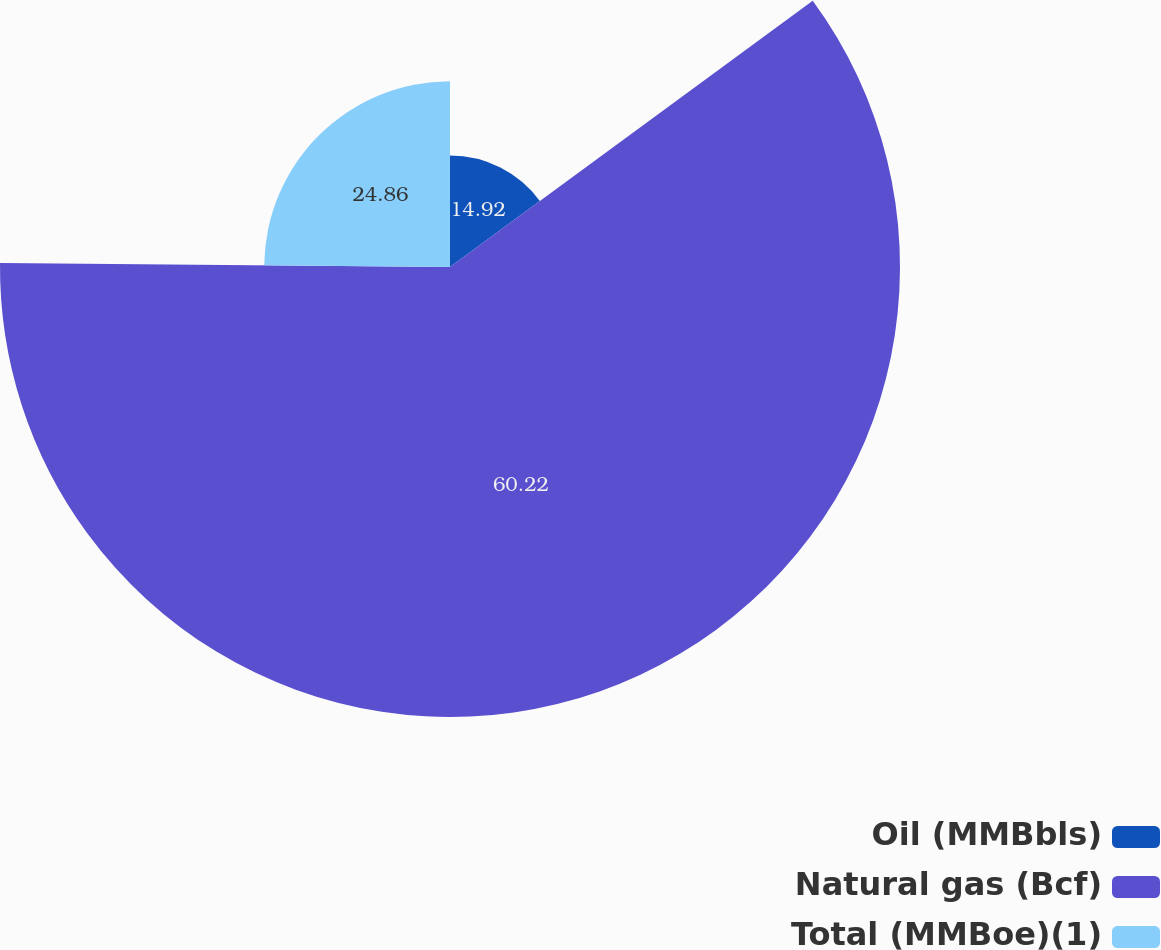<chart> <loc_0><loc_0><loc_500><loc_500><pie_chart><fcel>Oil (MMBbls)<fcel>Natural gas (Bcf)<fcel>Total (MMBoe)(1)<nl><fcel>14.92%<fcel>60.22%<fcel>24.86%<nl></chart> 